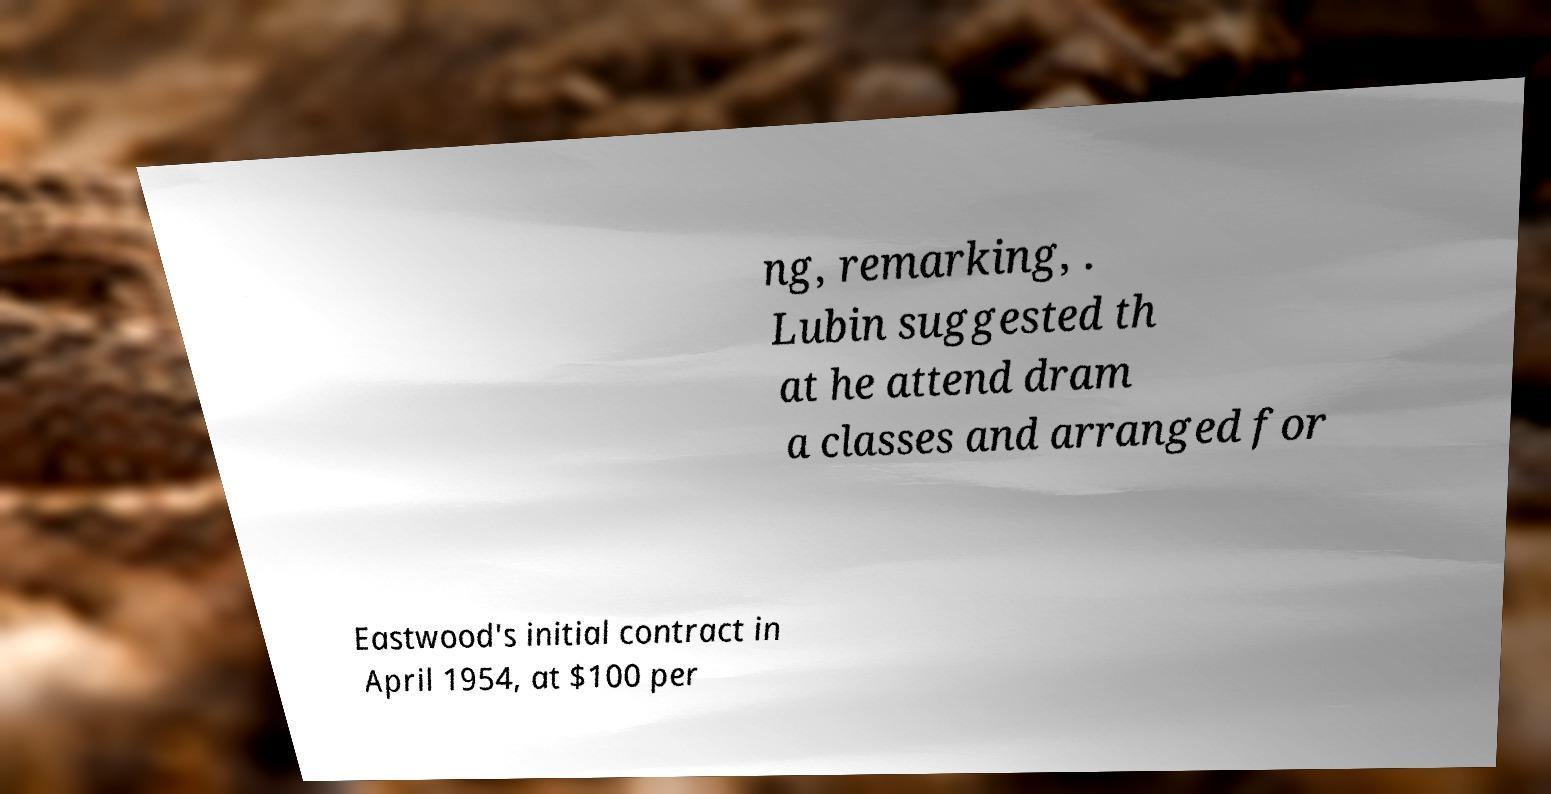Please identify and transcribe the text found in this image. ng, remarking, . Lubin suggested th at he attend dram a classes and arranged for Eastwood's initial contract in April 1954, at $100 per 